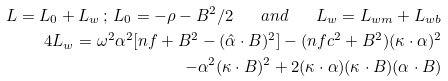Convert formula to latex. <formula><loc_0><loc_0><loc_500><loc_500>L = L _ { 0 } + L _ { w } \, ; \, L _ { 0 } = - \rho - B ^ { 2 } / 2 \quad a n d \quad L _ { w } = L _ { w m } + L _ { w b } \\ 4 L _ { w } = \omega ^ { 2 } \alpha ^ { 2 } [ n f + B ^ { 2 } - ( \hat { \alpha } \cdot B ) ^ { 2 } ] - ( n f c ^ { 2 } + B ^ { 2 } ) ( \kappa \cdot \alpha ) ^ { 2 } \\ - \alpha ^ { 2 } ( \kappa \cdot B ) ^ { 2 } + 2 ( \kappa \cdot \alpha ) ( \kappa \cdot B ) ( \alpha \cdot B )</formula> 